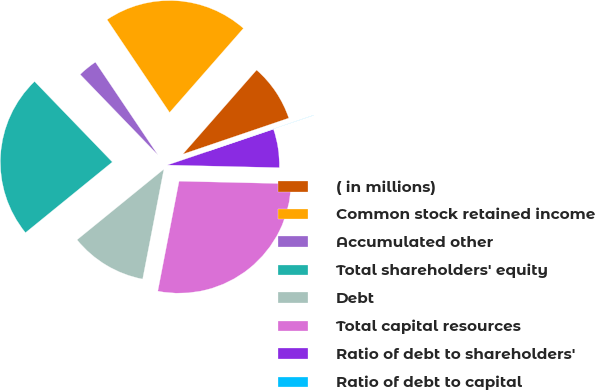Convert chart. <chart><loc_0><loc_0><loc_500><loc_500><pie_chart><fcel>( in millions)<fcel>Common stock retained income<fcel>Accumulated other<fcel>Total shareholders' equity<fcel>Debt<fcel>Total capital resources<fcel>Ratio of debt to shareholders'<fcel>Ratio of debt to capital<nl><fcel>8.32%<fcel>20.89%<fcel>2.79%<fcel>23.65%<fcel>11.09%<fcel>27.67%<fcel>5.56%<fcel>0.03%<nl></chart> 